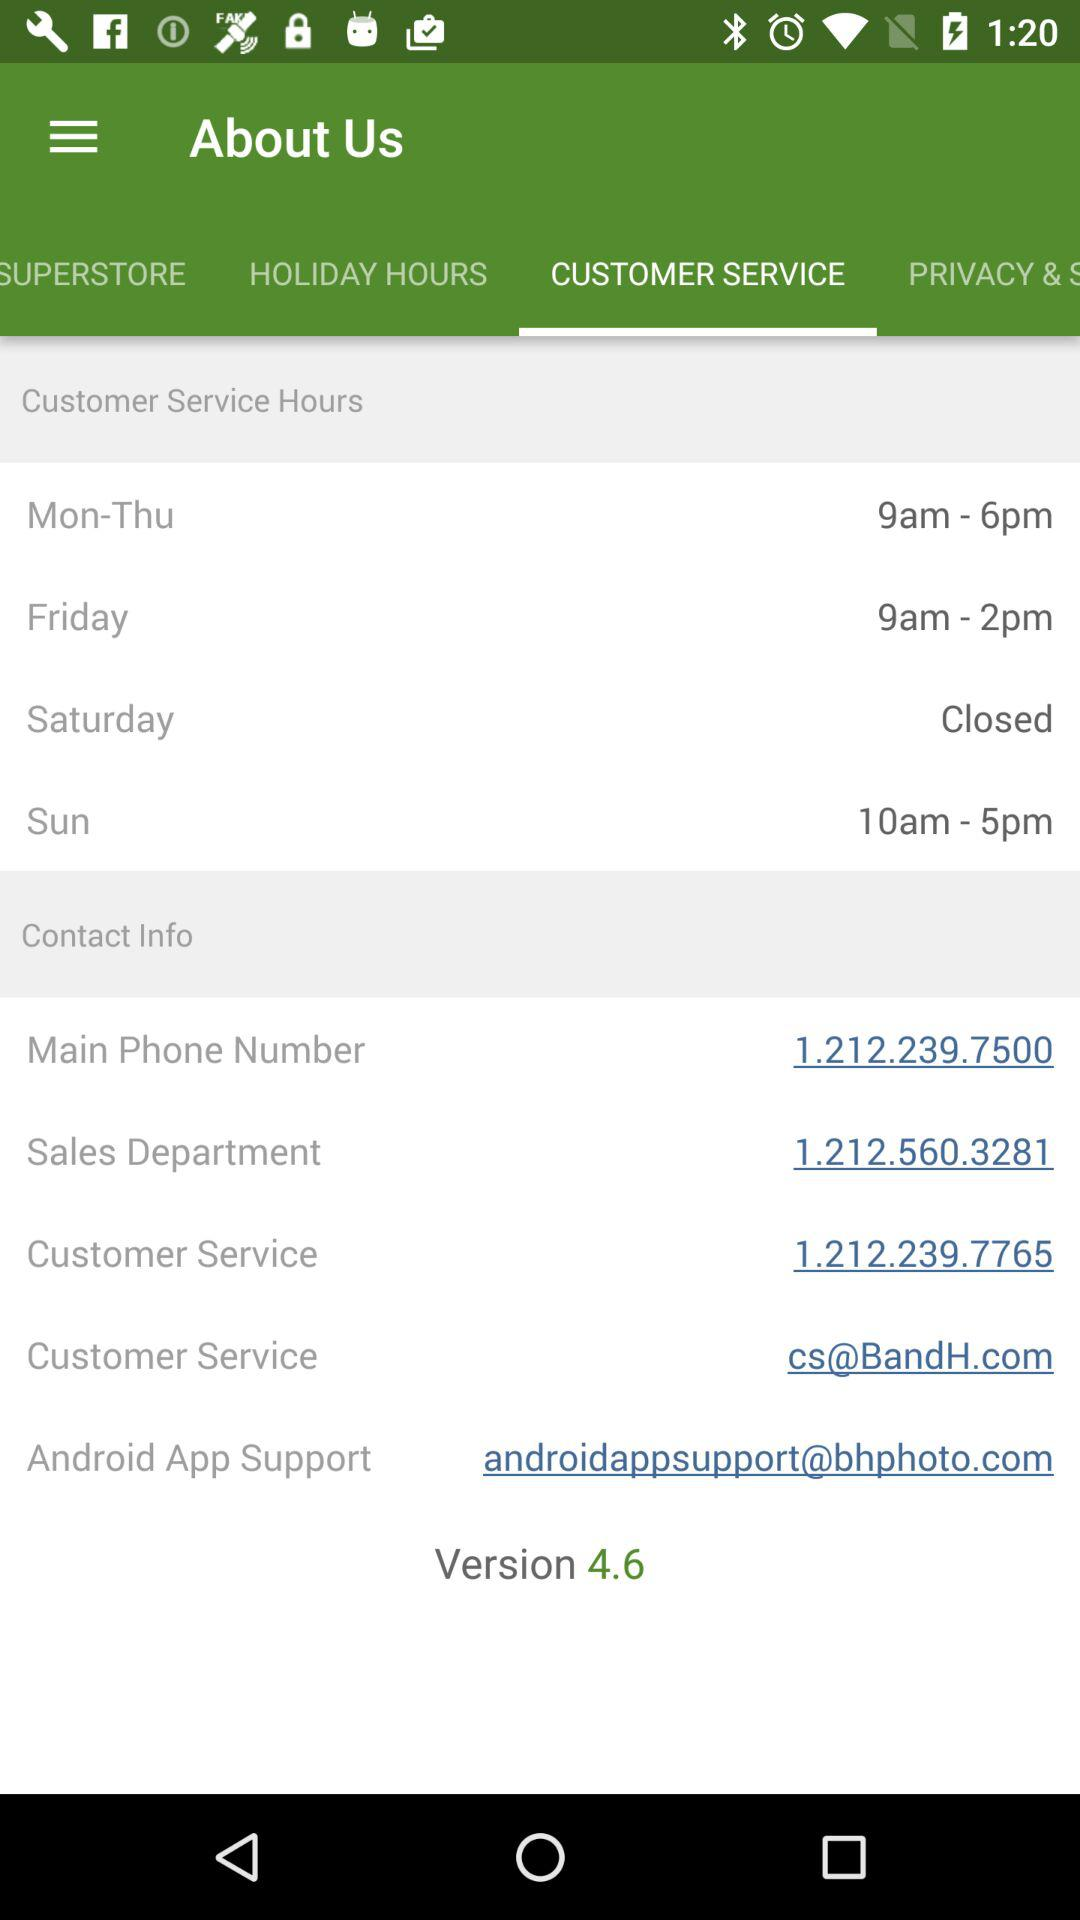How many different contact information options are there?
Answer the question using a single word or phrase. 5 